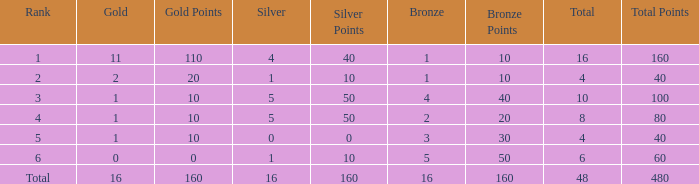How many gold are a rank 1 and larger than 16? 0.0. 